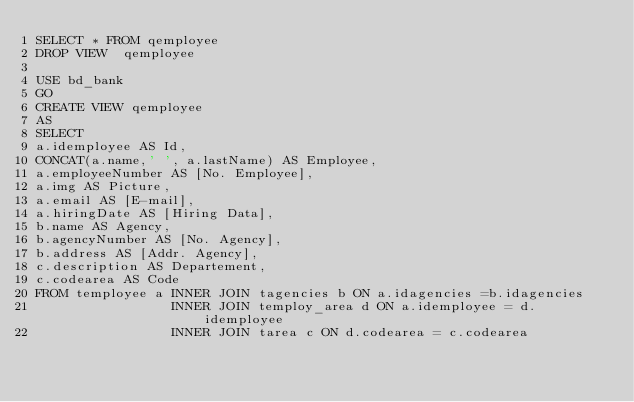Convert code to text. <code><loc_0><loc_0><loc_500><loc_500><_SQL_>SELECT * FROM qemployee
DROP VIEW  qemployee

USE bd_bank
GO					 
CREATE VIEW qemployee
AS
SELECT	
a.idemployee AS Id,
CONCAT(a.name,' ', a.lastName) AS Employee,
a.employeeNumber AS [No. Employee],
a.img AS Picture,
a.email AS [E-mail],
a.hiringDate AS [Hiring Data],
b.name AS Agency,
b.agencyNumber AS [No. Agency],
b.address AS [Addr. Agency],
c.description AS Departement,
c.codearea AS Code
FROM temployee a INNER JOIN tagencies b ON a.idagencies =b.idagencies
                 INNER JOIN temploy_area d ON a.idemployee = d.idemployee
                 INNER JOIN tarea c ON d.codearea = c.codearea</code> 